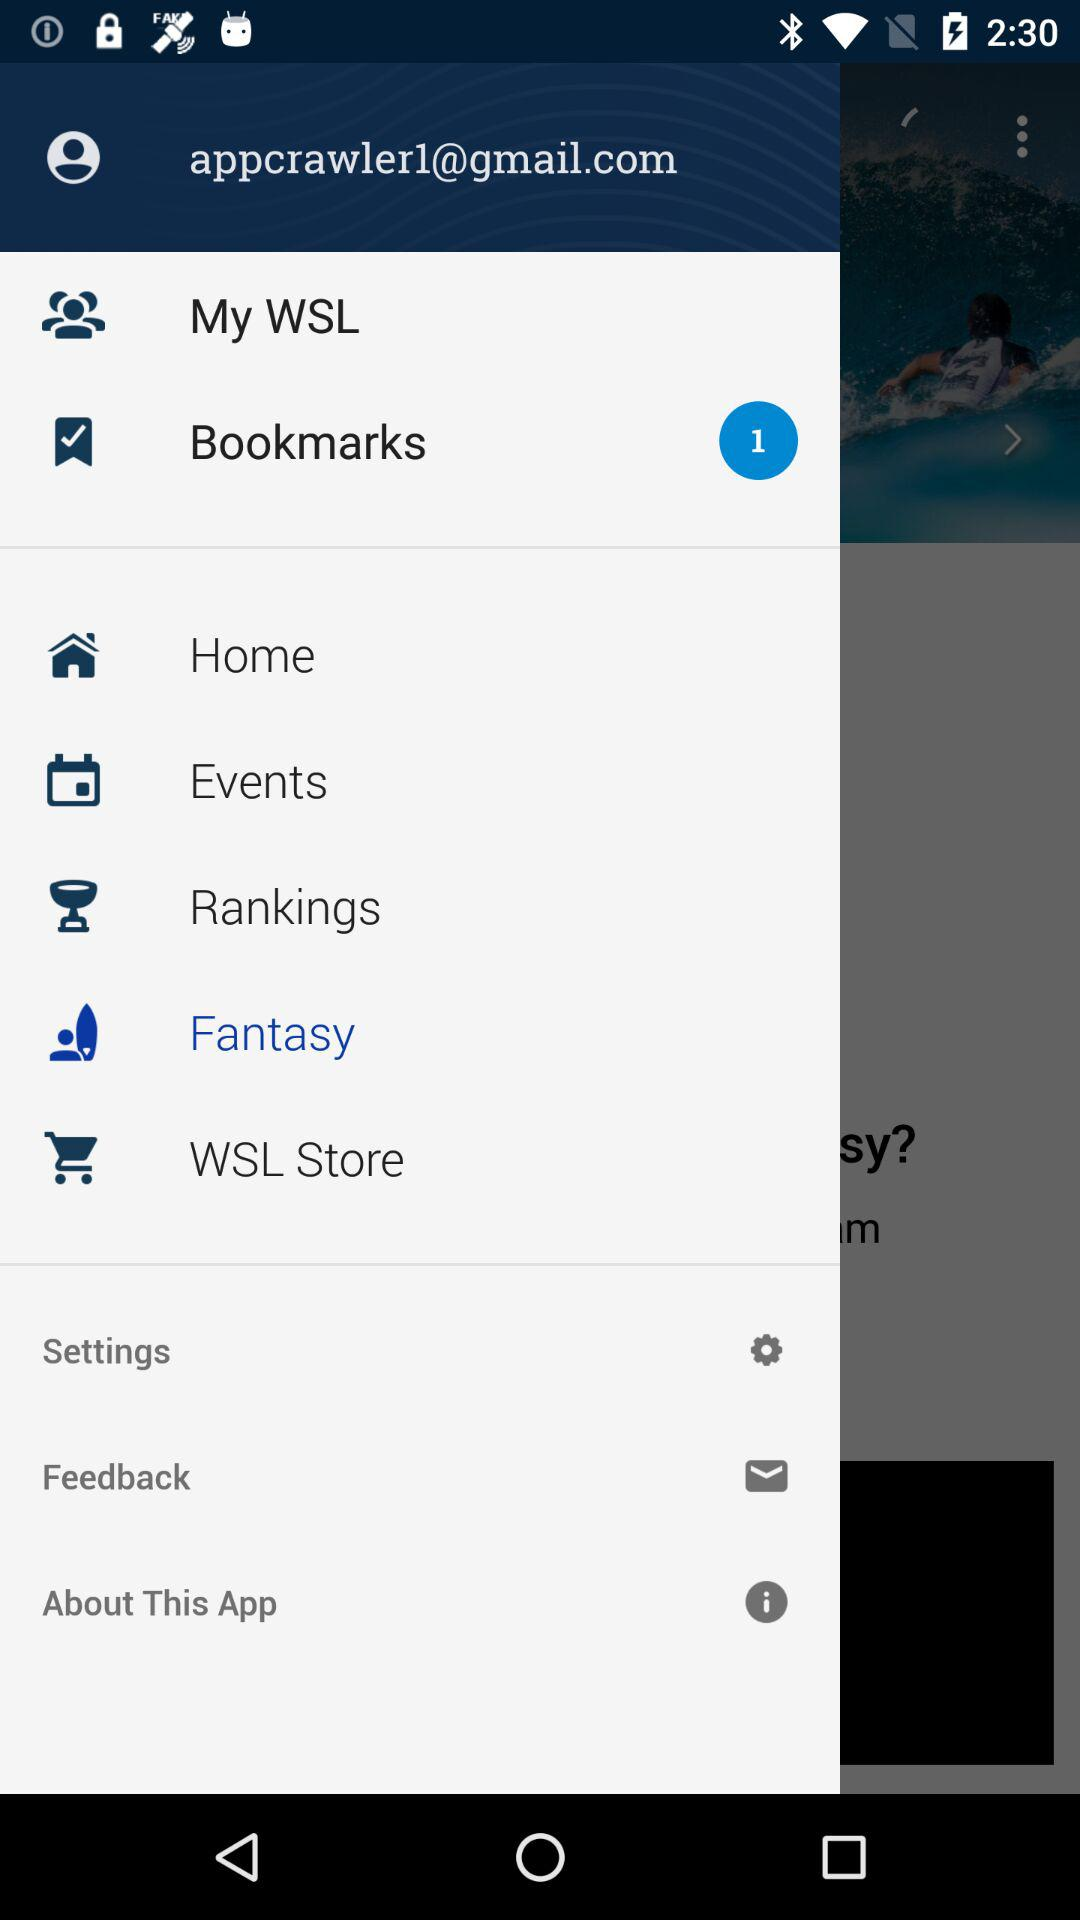How many bookmarks are there? There is 1 bookmark. 